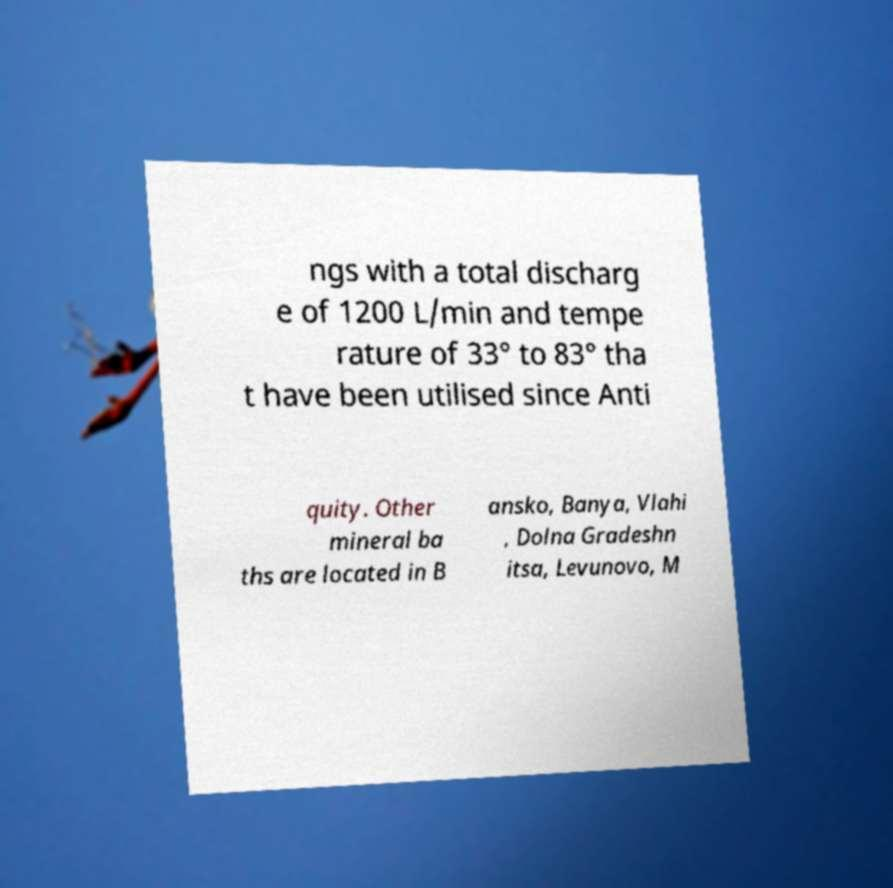There's text embedded in this image that I need extracted. Can you transcribe it verbatim? ngs with a total discharg e of 1200 L/min and tempe rature of 33° to 83° tha t have been utilised since Anti quity. Other mineral ba ths are located in B ansko, Banya, Vlahi , Dolna Gradeshn itsa, Levunovo, M 